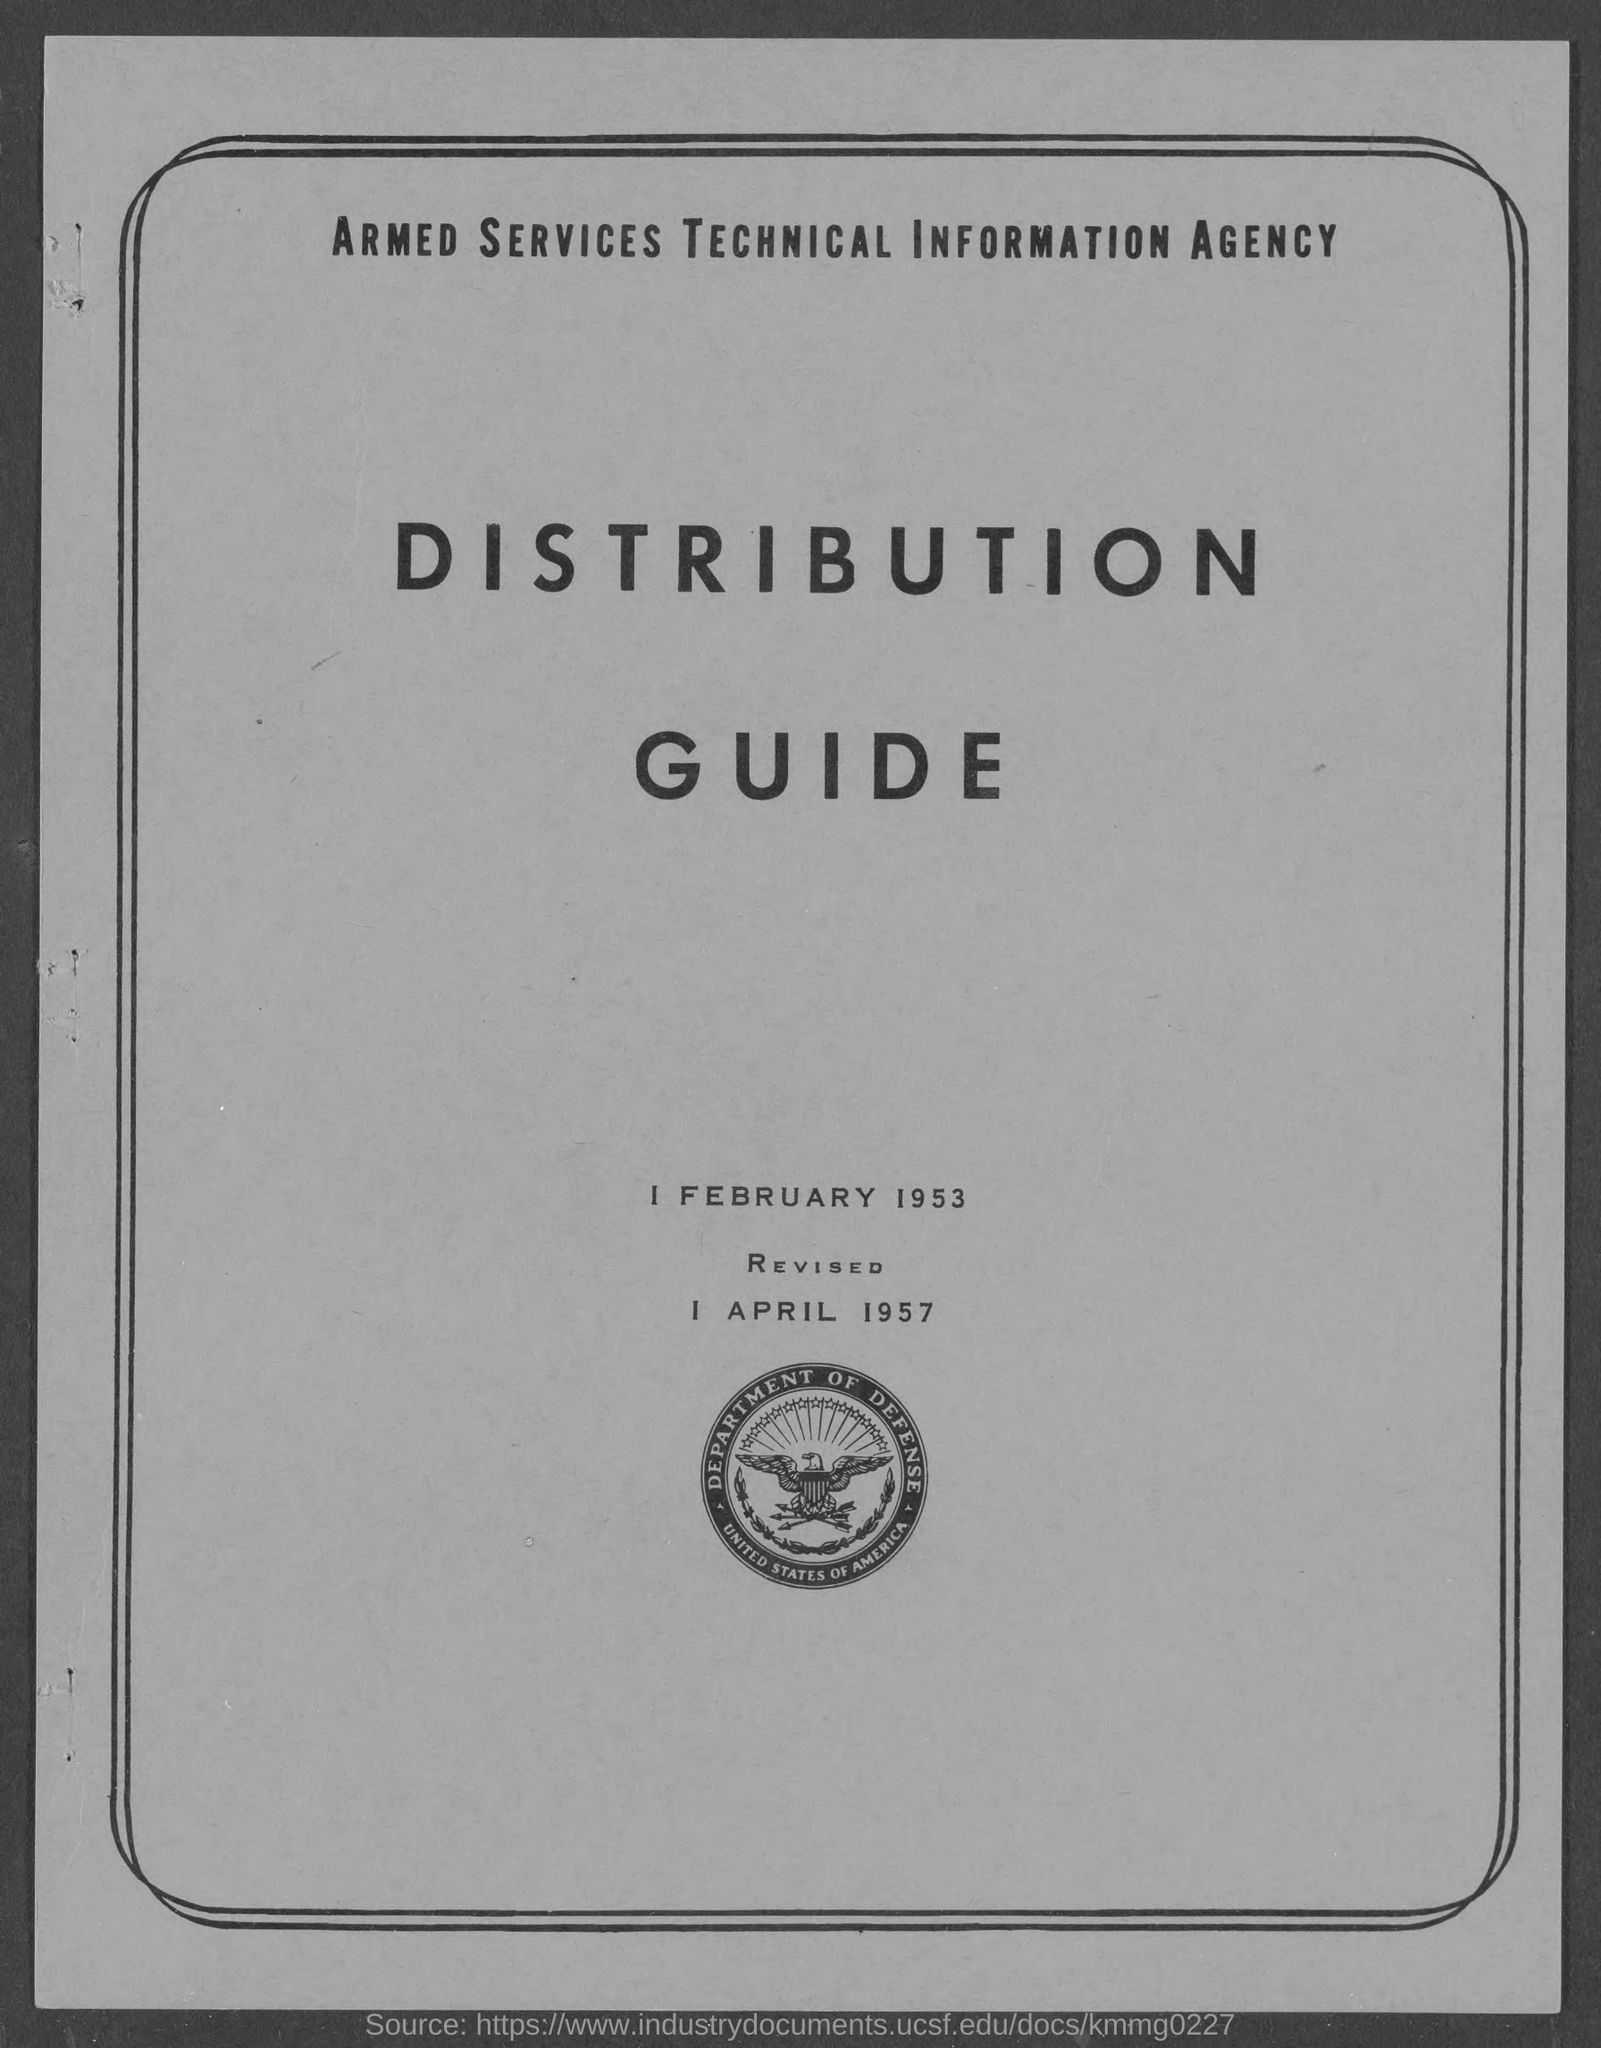Outline some significant characteristics in this image. The document was revised on April 1, 1957. The name of the country whose emblem bears the words "United States of America" is the United States of America. The Armed Services Technical Information Agency is the name of a government agency. The name of the department that is represented on the emblem is the Department of Defense. 